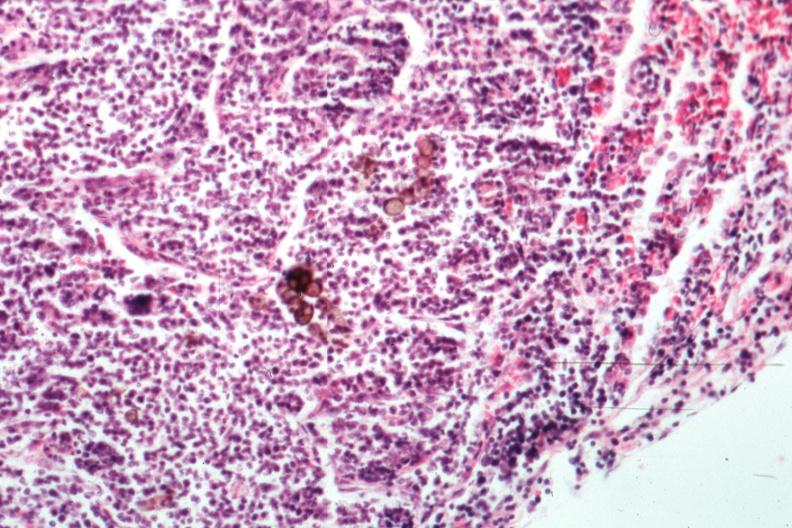s chromoblastomycosis present?
Answer the question using a single word or phrase. Yes 